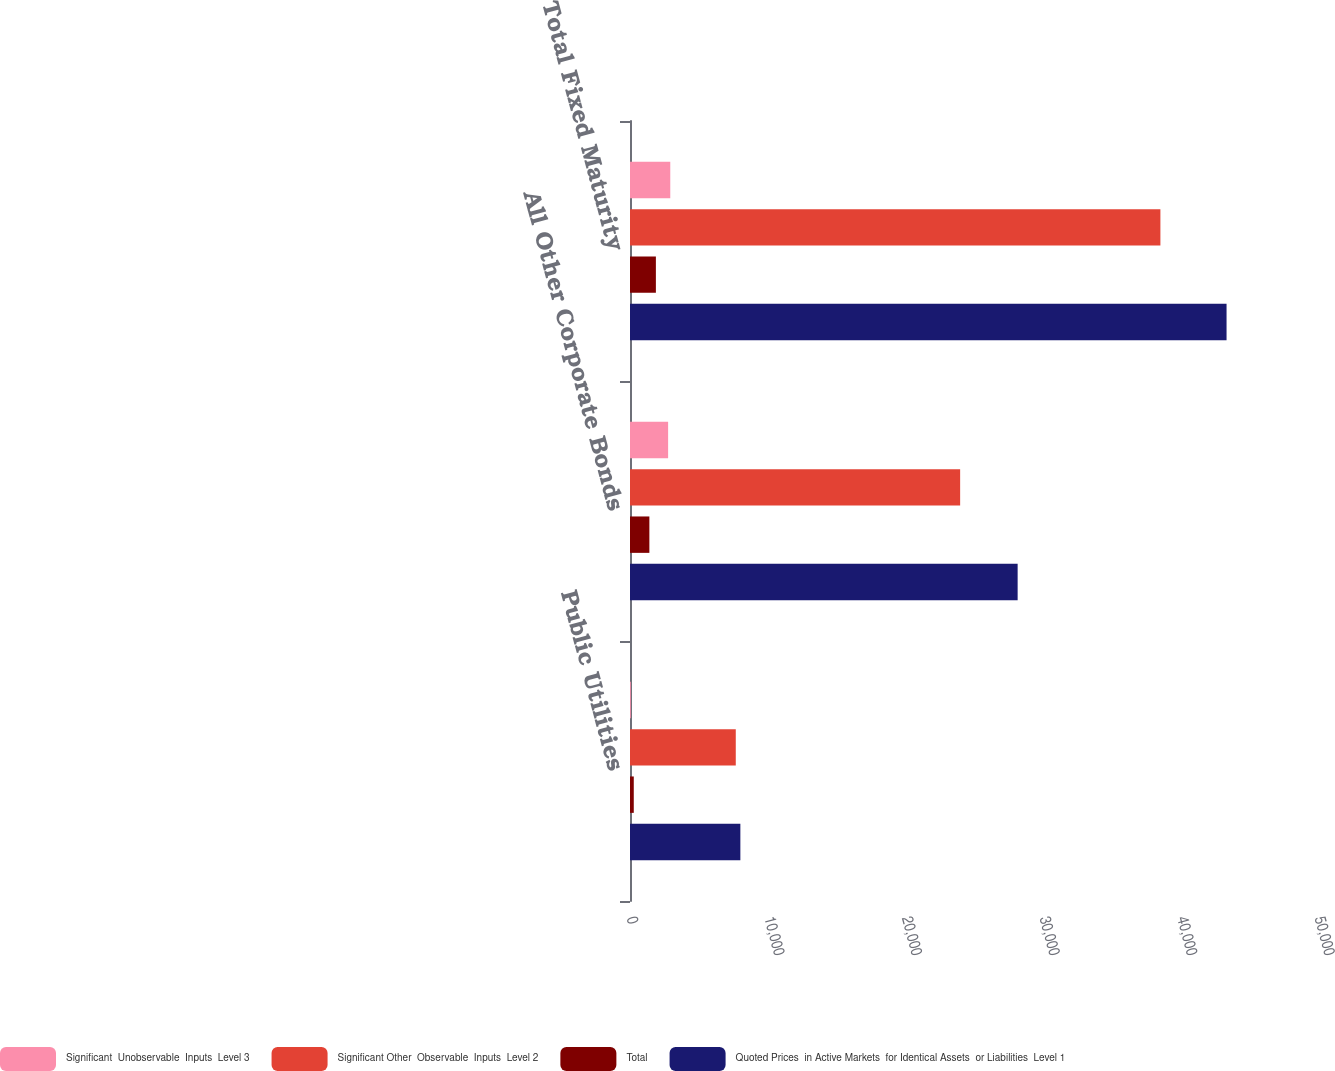<chart> <loc_0><loc_0><loc_500><loc_500><stacked_bar_chart><ecel><fcel>Public Utilities<fcel>All Other Corporate Bonds<fcel>Total Fixed Maturity<nl><fcel>Significant  Unobservable  Inputs  Level 3<fcel>59.1<fcel>2770.4<fcel>2926.8<nl><fcel>Significant Other  Observable  Inputs  Level 2<fcel>7687.2<fcel>23992.8<fcel>38546.4<nl><fcel>Total<fcel>274.1<fcel>1408.2<fcel>1881.2<nl><fcel>Quoted Prices  in Active Markets  for Identical Assets  or Liabilities  Level 1<fcel>8020.4<fcel>28171.4<fcel>43354.4<nl></chart> 